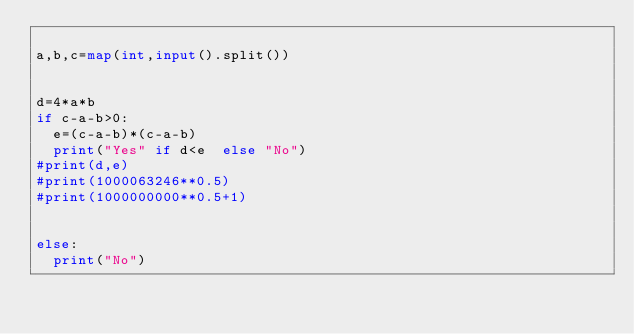<code> <loc_0><loc_0><loc_500><loc_500><_Python_>
a,b,c=map(int,input().split())


d=4*a*b
if c-a-b>0:
  e=(c-a-b)*(c-a-b)
  print("Yes" if d<e  else "No")
#print(d,e)
#print(1000063246**0.5)
#print(1000000000**0.5+1)


else:
  print("No")</code> 